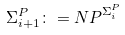<formula> <loc_0><loc_0><loc_500><loc_500>\Sigma _ { i + 1 } ^ { P } \colon = { N P } ^ { \Sigma _ { i } ^ { P } }</formula> 